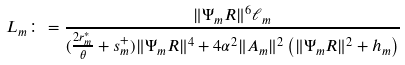<formula> <loc_0><loc_0><loc_500><loc_500>L _ { m } \colon = \frac { \| \Psi _ { m } R \| ^ { 6 } \ell _ { m } } { ( \frac { 2 r _ { m } ^ { * } } { \theta } + s _ { m } ^ { + } ) \| \Psi _ { m } R \| ^ { 4 } + 4 \alpha ^ { 2 } \| A _ { m } \| ^ { 2 } \left ( \| \Psi _ { m } R \| ^ { 2 } + h _ { m } \right ) }</formula> 